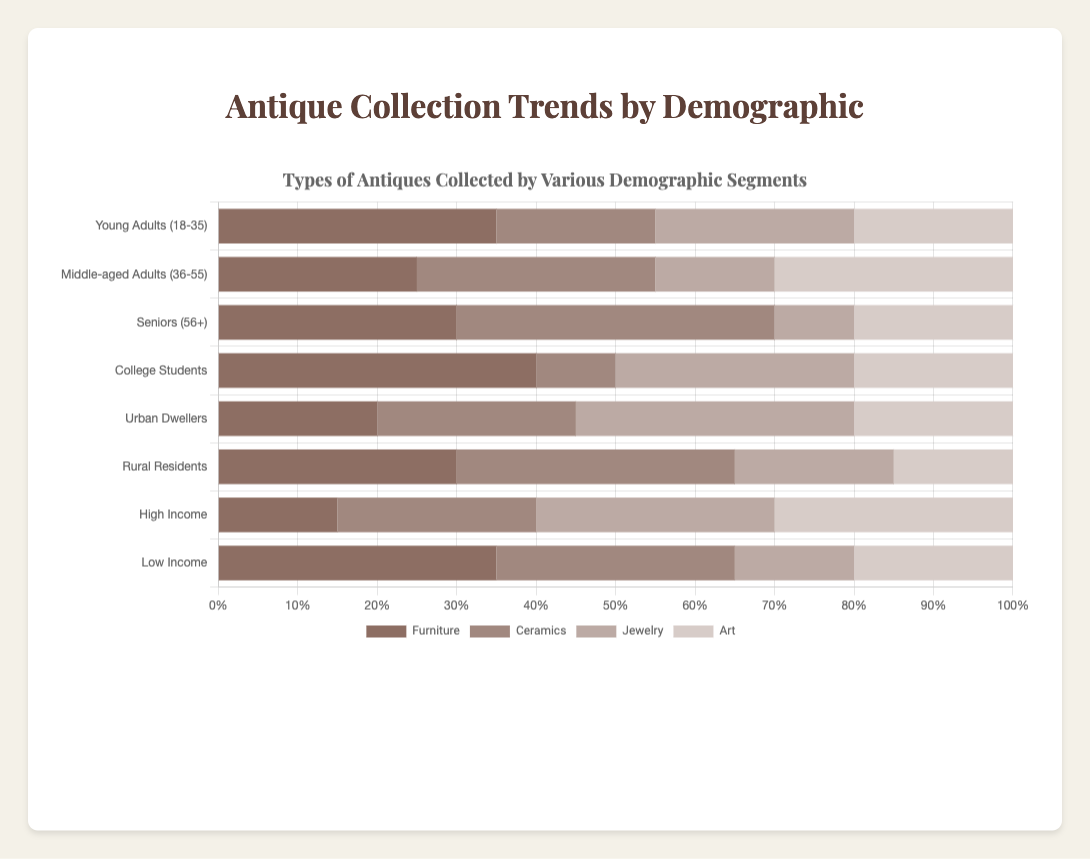What demographic segment has the highest percentage of individuals collecting furniture? The "College Students" segment has the highest percentage of individuals collecting furniture, which can be observed by comparing the length of the bars for the "Furniture" category across all demographic segments. The "College Students" bar is the longest.
Answer: College Students Which two demographic segments have the same percentage of individuals collecting art? By looking at the "Art" category for all demographic segments, both "Young Adults (18-35)" and "Low Income" segments have a bar of the same length, representing 20%.
Answer: Young Adults (18-35) and Low Income Which category is the least collected by "Urban Dwellers"? By examining the bar lengths under the "Urban Dwellers" demographic, the shortest bar corresponds to the "Furniture" category.
Answer: Furniture How many total categories do "Middle-aged Adults (36-55)" collect at 30% or more? Checking the bar lengths under the "Middle-aged Adults (36-55)" segment, the "Ceramics" and "Art" categories both have bars at 30%. So there are 2 categories where collection is 30% or more.
Answer: 2 What is the average percentage of "Furniture" collection across all demographic segments? The segments have the following Furniture collection values: 35, 25, 30, 40, 20, 30, 15, 35. Summing these values gives 230. To find the average, divide by 8 (number of segments): 230 / 8 = 28.75
Answer: 28.75% Which category has the highest collection percentage among "Seniors (56+)"? For the "Seniors (56+)" segment, the highest bar is for the "Ceramics" category at 40%.
Answer: Ceramics Is the percentage of individuals collecting jewelry higher in "Urban Dwellers" or "Middle-aged Adults (36-55)"? The bar for Jewelry under "Urban Dwellers" is at 35%, while for "Middle-aged Adults (36-55)" it is at 15%. Therefore, "Urban Dwellers" have a higher percentage.
Answer: Urban Dwellers What is the difference in the percentage of ceramics collected between "Young Adults (18-35)" and "Rural Residents"? The "Young Adults (18-35)" collect ceramics at 20%, while "Rural Residents" collect at 35%. The difference is 35% - 20% = 15%.
Answer: 15% Which demographic group has the most diverse interests (i.e., more equal distribution in the collection categories)? The "Middle-aged Adults (36-55)" segment shows a relatively balanced distribution in collecting Furniture, Ceramics, Jewelry, and Art, suggested by the comparatively even lengths of their bars in each category.
Answer: Middle-aged Adults (36-55) What is the total percentage of antiques collected (all types) by "High Income" individuals? Summing the percentages for "High Income" across all categories: 15 (Furniture) + 25 (Ceramics) + 30 (Jewelry) + 30 (Art) = 100%.
Answer: 100% 